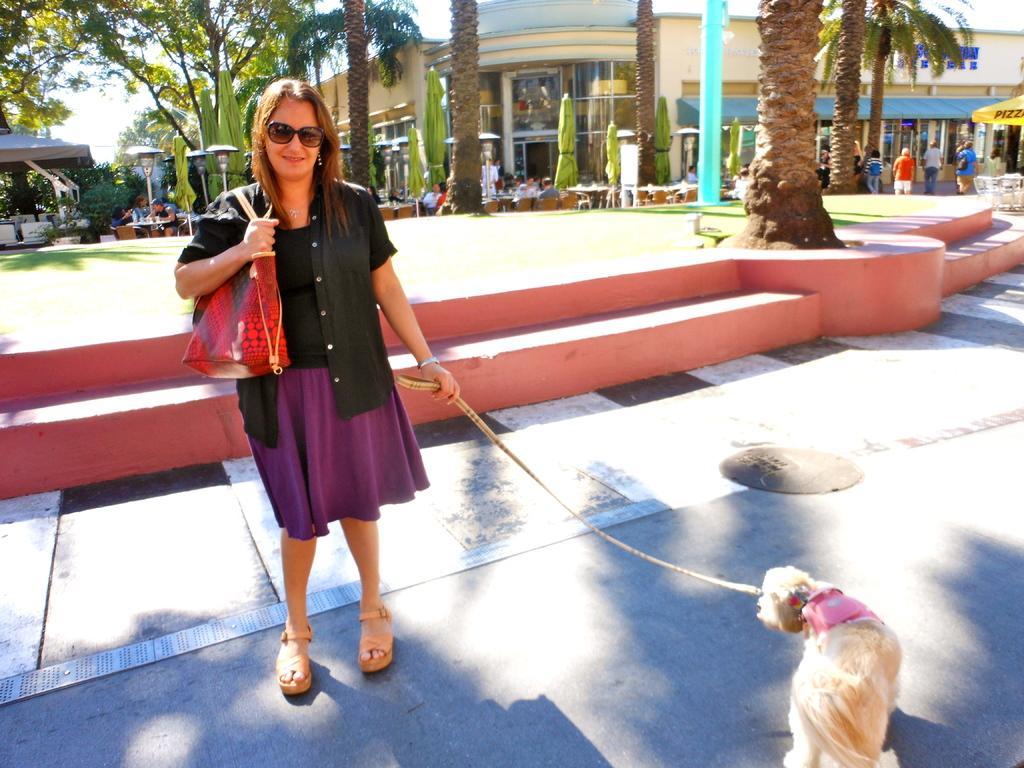Describe this image in one or two sentences. In this image there is a woman standing with her dog on a road, in the background there are trees, tables, chairs and shops. 